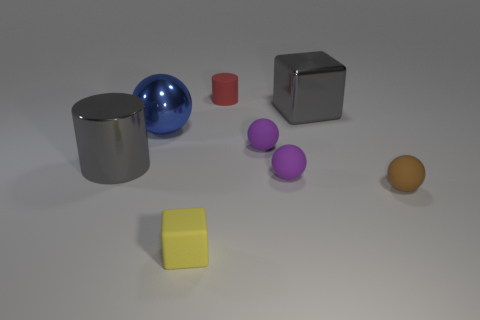Given the arrangement of objects, what kind of setting could this represent? The arrangement of these geometric shapes on a flat surface could represent an educational setting where basic forms and colors are used for learning, or an artist's composition studying the interplay between shape, color, and light. 